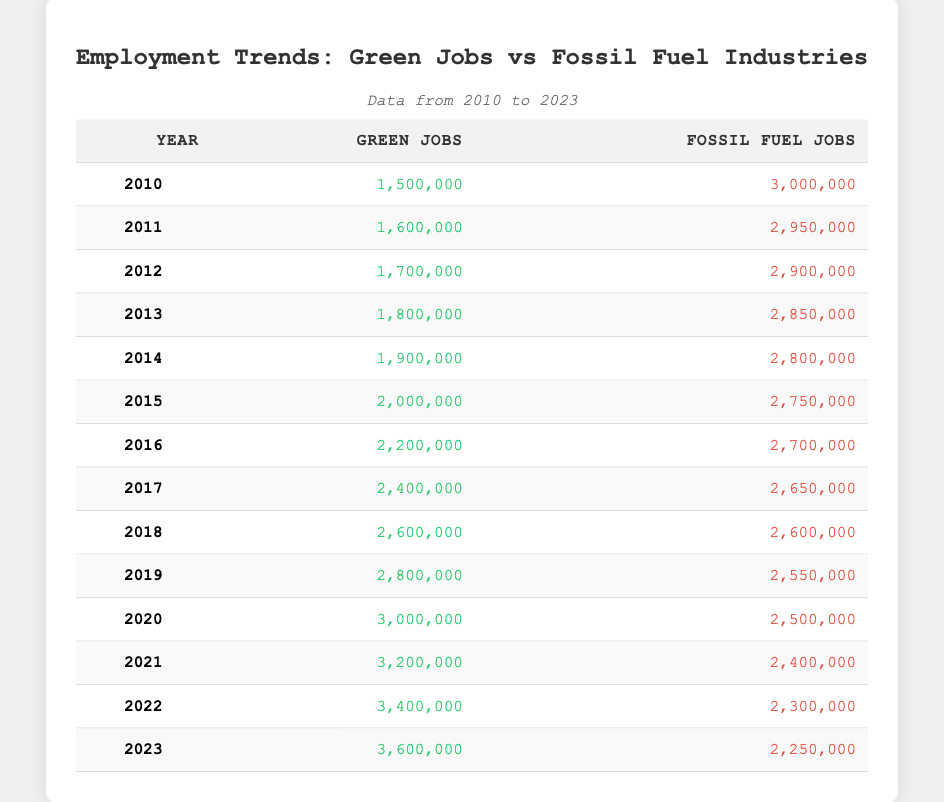What was the total number of green jobs in 2015? The table shows that in 2015, there were 2,000,000 green jobs.
Answer: 2,000,000 In which year did green jobs first exceed fossil fuel jobs? The table indicates that in 2018, green jobs (2,600,000) were equal to fossil fuel jobs (2,600,000). In 2019, green jobs surpassed fossil fuel jobs (2,800,000 vs 2,550,000).
Answer: 2019 What is the difference in the number of fossil fuel jobs between 2010 and 2023? In 2010, there were 3,000,000 fossil fuel jobs, and in 2023, there were 2,250,000. The difference is 3,000,000 - 2,250,000 = 750,000.
Answer: 750,000 What was the percentage increase in green jobs from 2010 to 2023? In 2010, there were 1,500,000 green jobs, and in 2023, there were 3,600,000. The increase is (3,600,000 - 1,500,000) = 2,100,000. To find the percentage increase: (2,100,000 / 1,500,000) * 100 = 140%.
Answer: 140% How many years saw a decrease in fossil fuel jobs compared to the previous year? By reviewing the table, fossil fuel jobs decreased in 2011, 2012, 2013, 2014, 2015, 2016, 2017, 2018, 2019, 2020, 2021, 2022, and 2023. They decreased in a total of 11 out of 13 years.
Answer: 11 Is it true that the number of green jobs consistently increased every year from 2010 to 2023? By examining the table, green jobs increased each year from 2010 (1,500,000) to 2023 (3,600,000) without any decrease in between.
Answer: Yes What was the average number of fossil fuel jobs from 2010 to 2023? To calculate the average, first sum all fossil fuel jobs: (3,000,000 + 2,950,000 + 2,900,000 + 2,850,000 + 2,800,000 + 2,750,000 + 2,700,000 + 2,650,000 + 2,600,000 + 2,550,000 + 2,500,000 + 2,400,000 + 2,300,000 + 2,250,000) = 35,600,000. Divide this by 14 years: 35,600,000 / 14 = 2,540,000.
Answer: 2,540,000 In which year did the gap between green jobs and fossil fuel jobs reach its maximum? The maximum gap occurred in 2021 when green jobs were 3,200,000, and fossil fuel jobs were 2,400,000, resulting in a gap of 800,000 jobs.
Answer: 2021 What trend do you observe regarding the employment in fossil fuel jobs over these years? The table shows a clear downward trend in fossil fuel jobs, decreasing consistently from 3,000,000 in 2010 to 2,250,000 in 2023.
Answer: Decreasing trend 